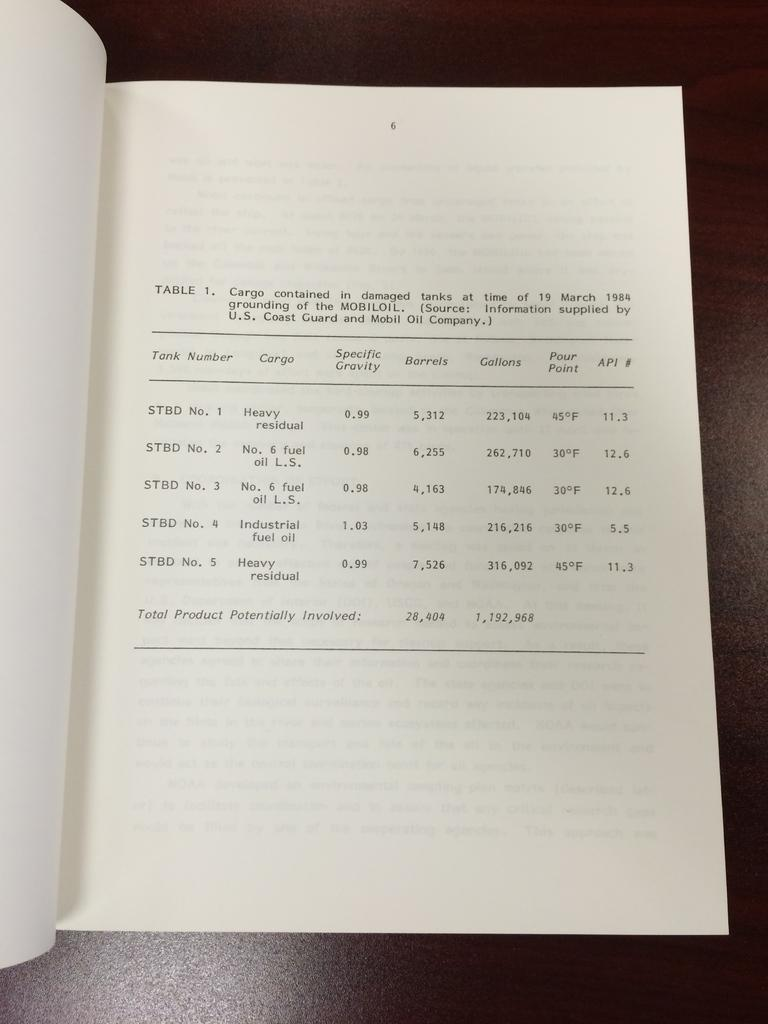Provide a one-sentence caption for the provided image. A log book listing the cargo on a ship, such as six barrels of oil. 